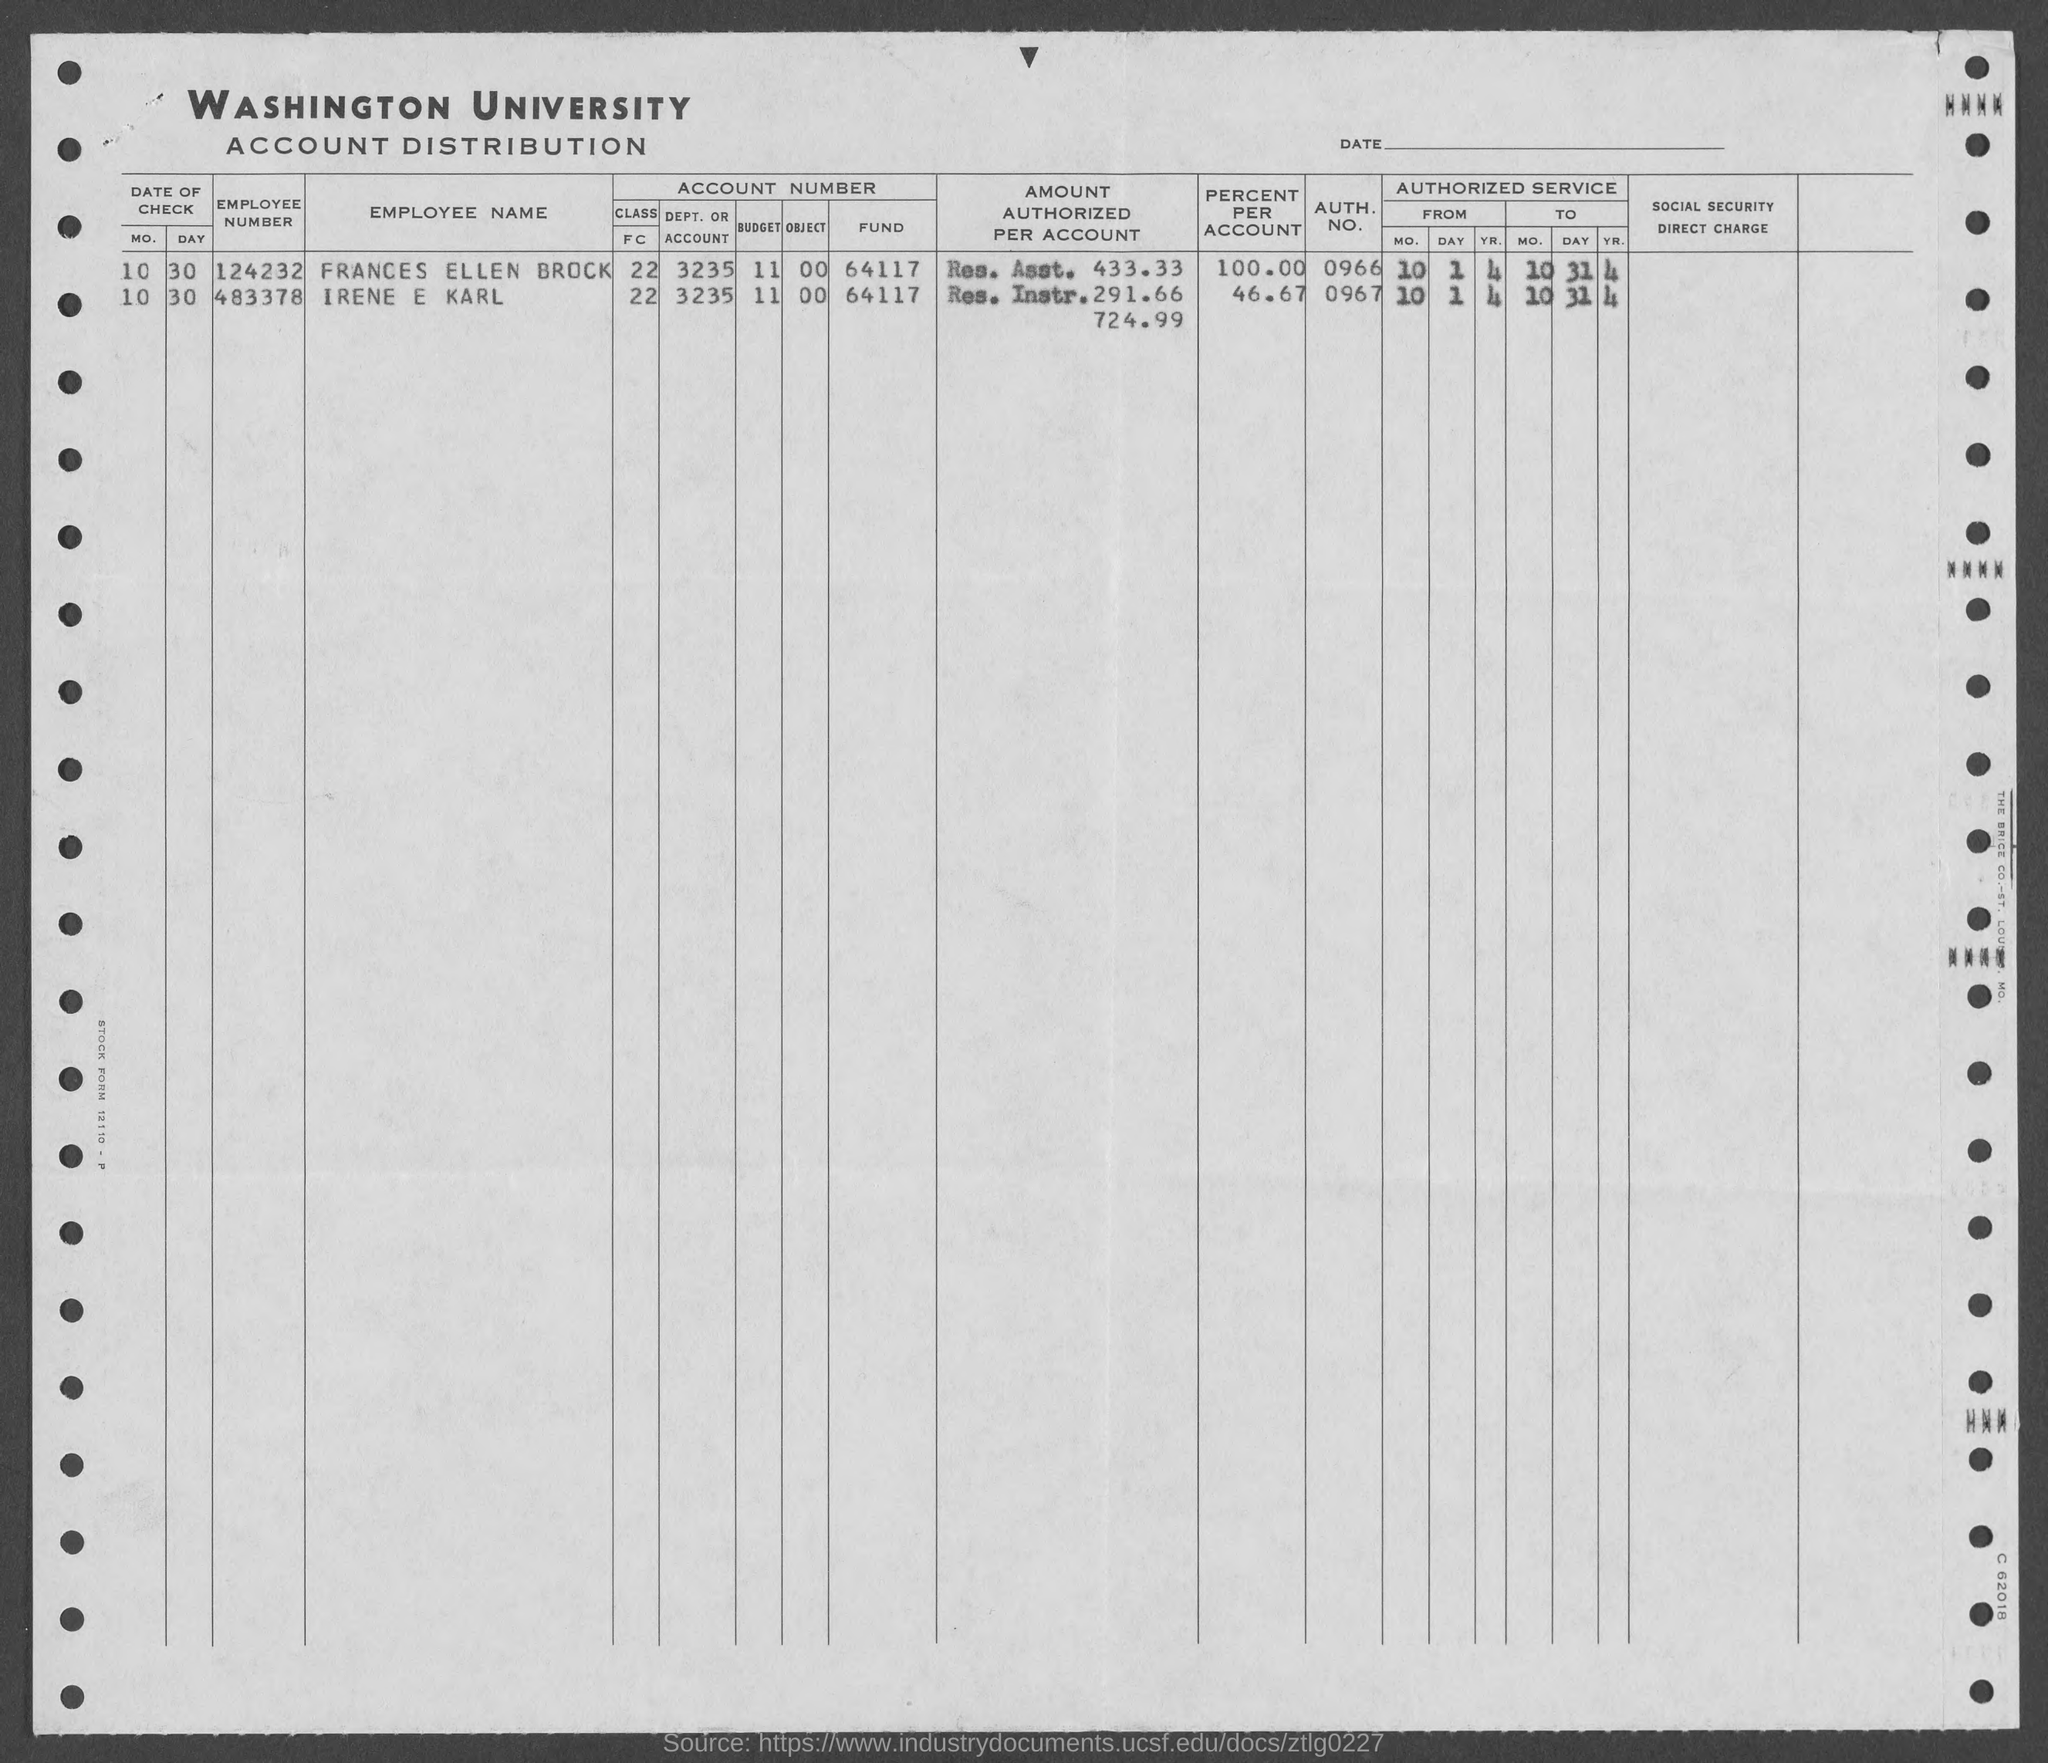Is there any information about the date on this document? Yes, the document lists dates in a 'MM DD' format at the top under 'DATE', with entries such as '10 30' likely indicating the 30th day of the 10th month. However, there is no year indicated, so the exact year of the document remains unknown. 